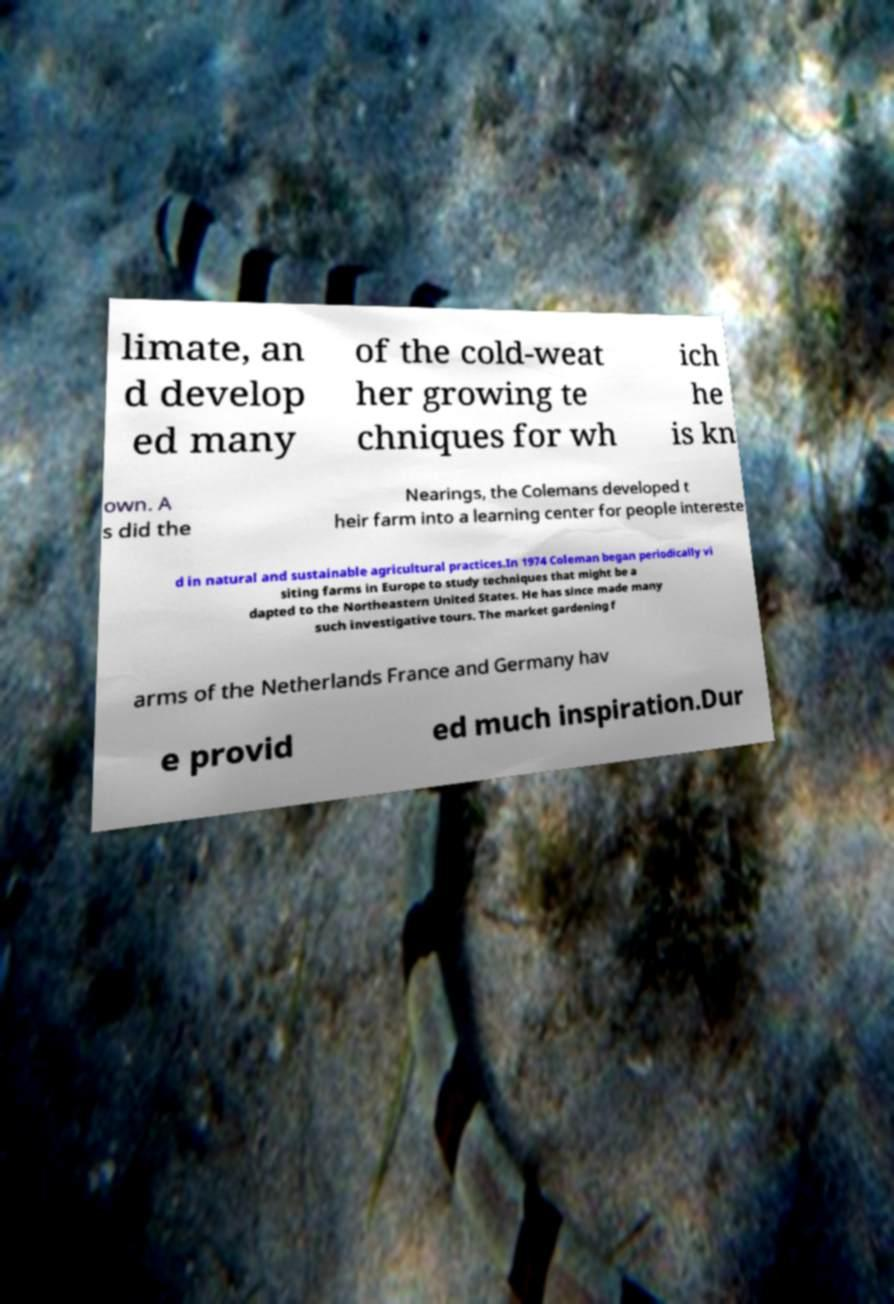Could you extract and type out the text from this image? limate, an d develop ed many of the cold-weat her growing te chniques for wh ich he is kn own. A s did the Nearings, the Colemans developed t heir farm into a learning center for people intereste d in natural and sustainable agricultural practices.In 1974 Coleman began periodically vi siting farms in Europe to study techniques that might be a dapted to the Northeastern United States. He has since made many such investigative tours. The market gardening f arms of the Netherlands France and Germany hav e provid ed much inspiration.Dur 